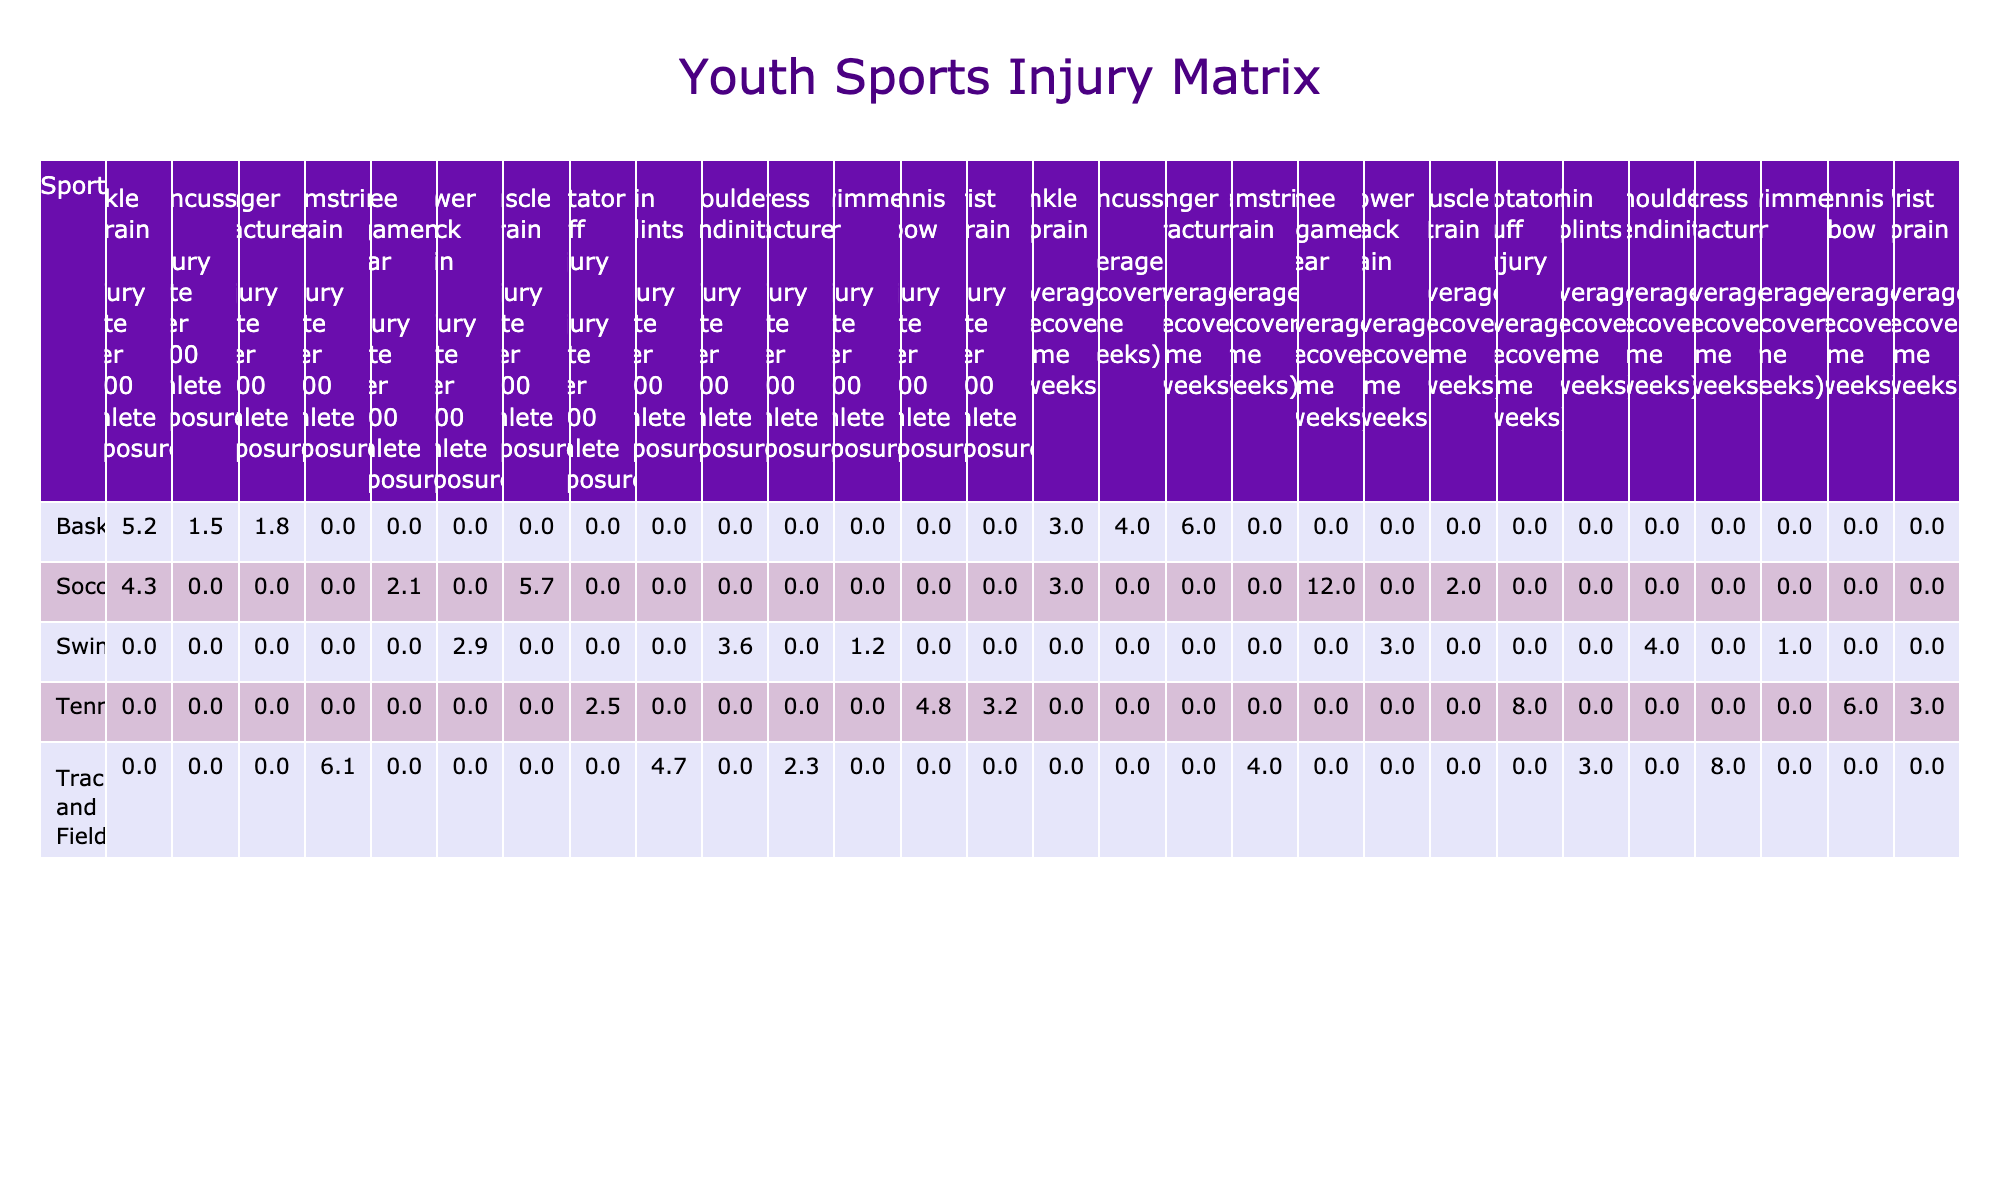What is the injury rate for ankle sprains in soccer? According to the table, the injury rate for ankle sprains specifically in soccer is listed as 4.3 per 1000 athlete exposures.
Answer: 4.3 What is the average recovery time for a knee ligament tear in soccer? The table shows that the average recovery time for a knee ligament tear in soccer is 12 weeks.
Answer: 12 weeks Which sport has the highest injury rate for muscle strains? Looking at the table, track and field has a muscle strain injury rate of 6.1 per 1000 athlete exposures, which is higher than any other sport listed for that injury type.
Answer: Track and field Is the average recovery time for a finger fracture in basketball longer than that for a shoulder tendinitis in swimming? The average recovery time for a finger fracture in basketball is 6 weeks, while for shoulder tendinitis in swimming it is 4 weeks. Since 6 is greater than 4, the average recovery time for the finger fracture is indeed longer.
Answer: Yes What is the total injury rate for all types of injuries in basketball? To find this, we add the injury rates for all injury types in basketball: 5.2 (ankle sprain) + 1.8 (finger fracture) + 1.5 (concussion) = 8.5 per 1000 athlete exposures.
Answer: 8.5 Which two sports have the same average recovery time for ankle sprains? Both soccer and basketball have the same average recovery time of 3 weeks for ankle sprains, as indicated in the table.
Answer: Soccer and basketball Among the sports listed, which injury type has the longest average recovery time? The longest average recovery time is for a knee ligament tear in soccer, which takes 12 weeks to recover, according to the table.
Answer: Knee ligament tear in soccer What is the difference in average recovery time between a rotator cuff injury in tennis and a stress fracture in track and field? The average recovery time for a rotator cuff injury in tennis is 8 weeks, while for a stress fracture in track and field it’s also 8 weeks. The difference is 8 - 8 = 0; therefore, they have the same recovery time.
Answer: 0 weeks Which sport has the highest average recovery time overall? To determine this, we look at the average recovery times across all injuries for each sport. The sport with the highest individual injury recovery time is soccer (12 weeks for knee ligament tear), which is the maximum in the table.
Answer: Soccer If you sum the injury rates for all sports combined, what value do you get? To find this, we sum all listed injury rates: 4.3 + 2.1 + 5.7 + 5.2 + 1.8 + 1.5 + 3.6 + 2.9 + 1.2 + 4.8 + 3.2 + 2.5 + 6.1 + 4.7 + 2.3 = 46.4 per 1000 athlete exposures.
Answer: 46.4 